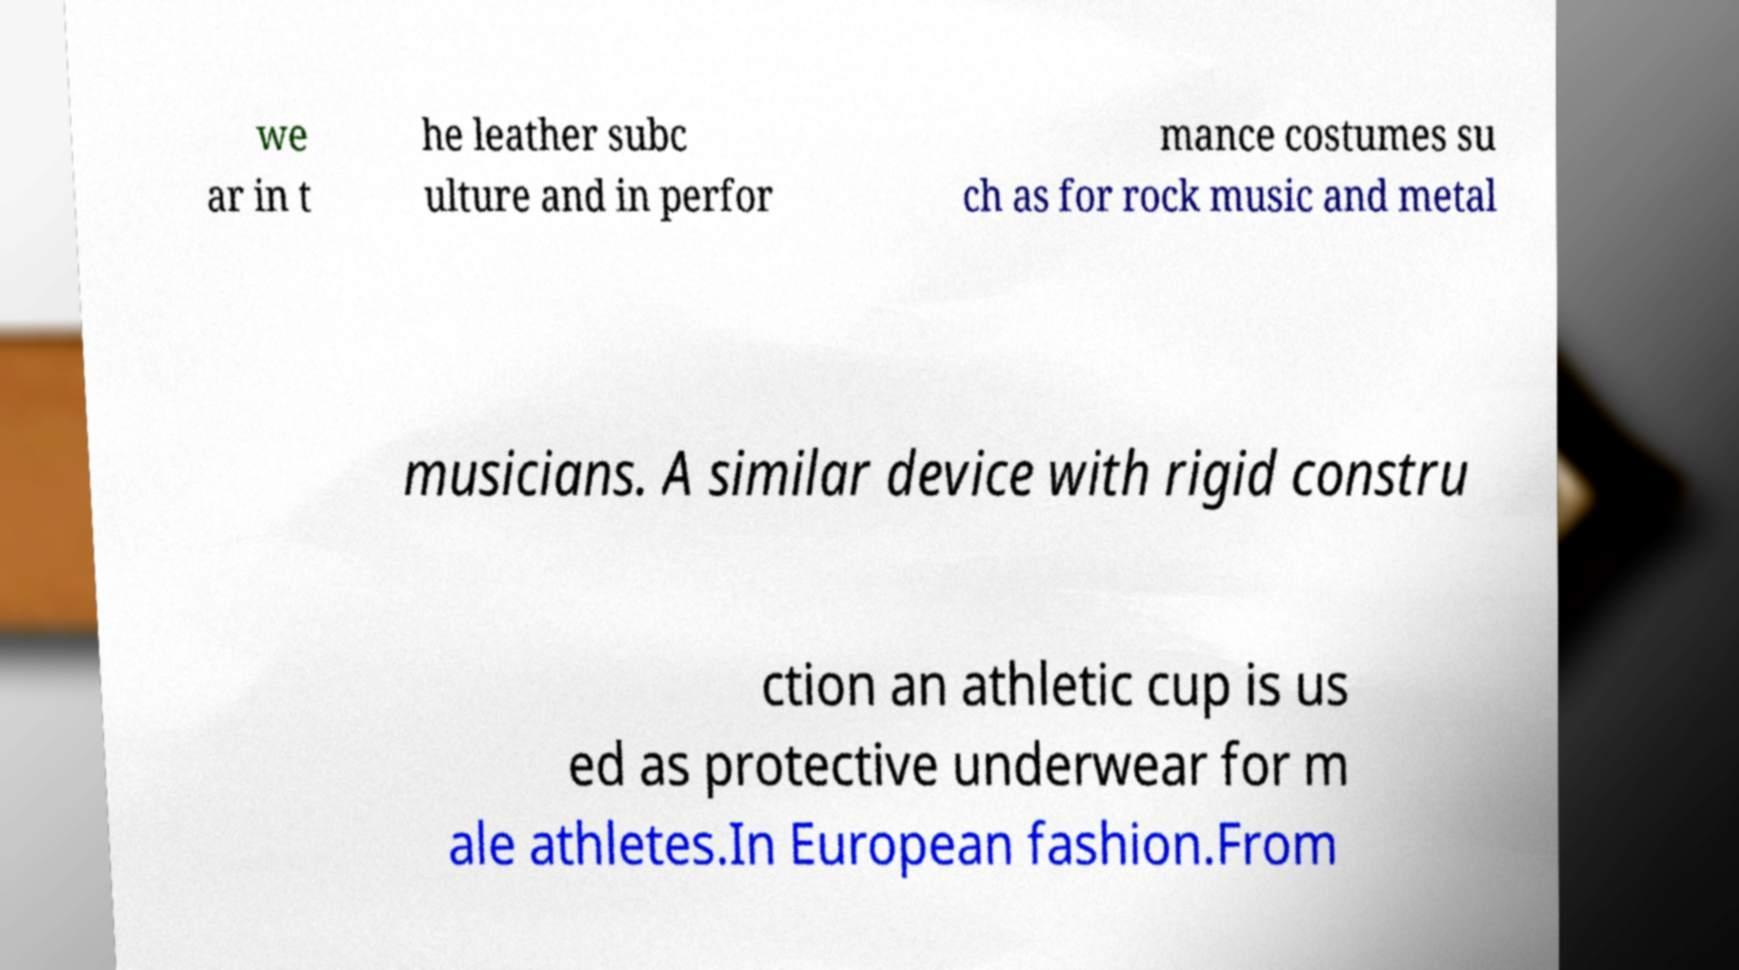For documentation purposes, I need the text within this image transcribed. Could you provide that? we ar in t he leather subc ulture and in perfor mance costumes su ch as for rock music and metal musicians. A similar device with rigid constru ction an athletic cup is us ed as protective underwear for m ale athletes.In European fashion.From 